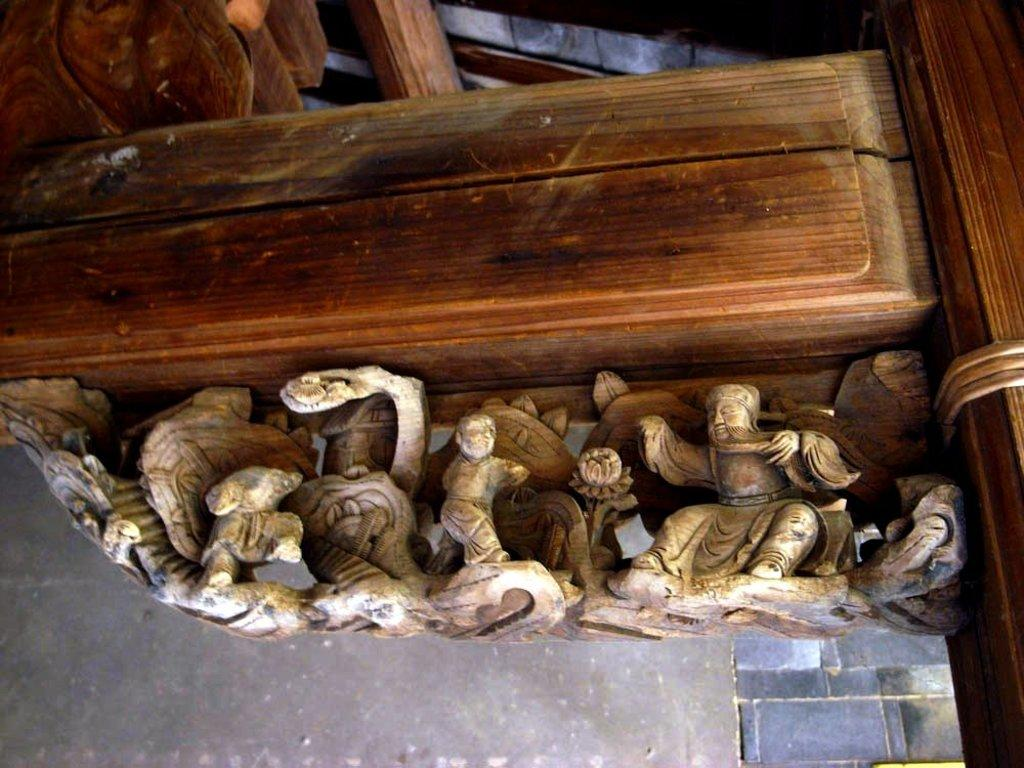What is the main object in the center of the image? There is a wooden stick in the center of the image. What else can be seen in the center of the image? There are sculptures in the center of the image. What is the surface that the wooden stick and sculptures are resting on? There is a floor at the bottom of the image. What type of thunder can be heard in the image? There is no thunder present in the image; it is a still image with no sound. 